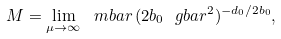Convert formula to latex. <formula><loc_0><loc_0><loc_500><loc_500>M = \lim _ { \mu \to \infty } \ m b a r \, ( 2 b _ { 0 } \ g b a r ^ { 2 } ) ^ { - d _ { 0 } / 2 b _ { 0 } } ,</formula> 